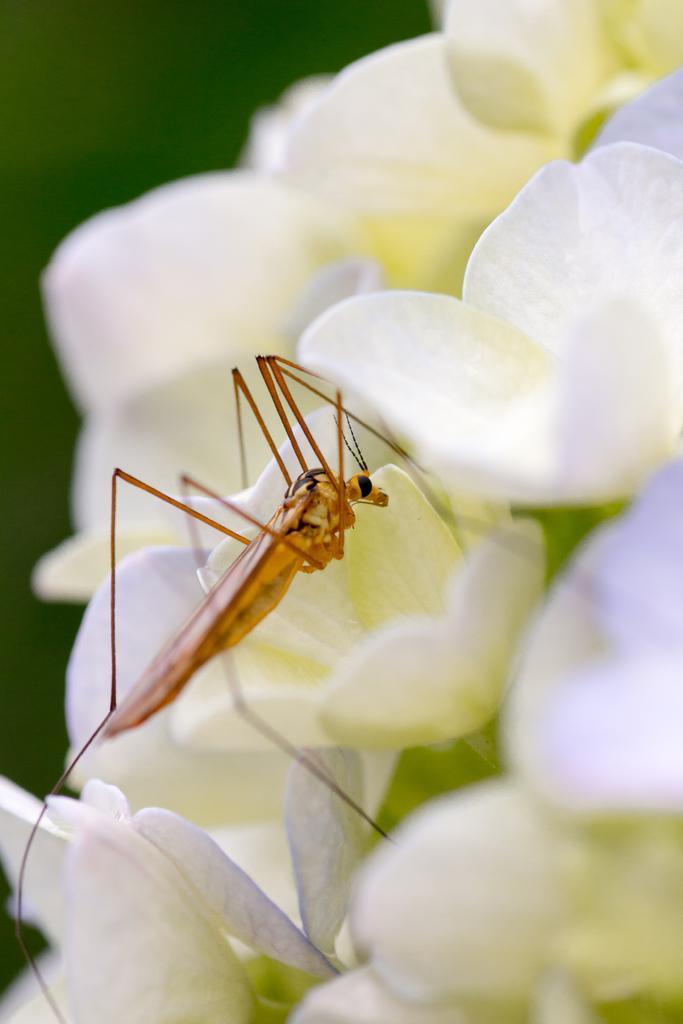Can you describe this image briefly? There are white flowers. On that there is an insect. In the background it is blurred. 